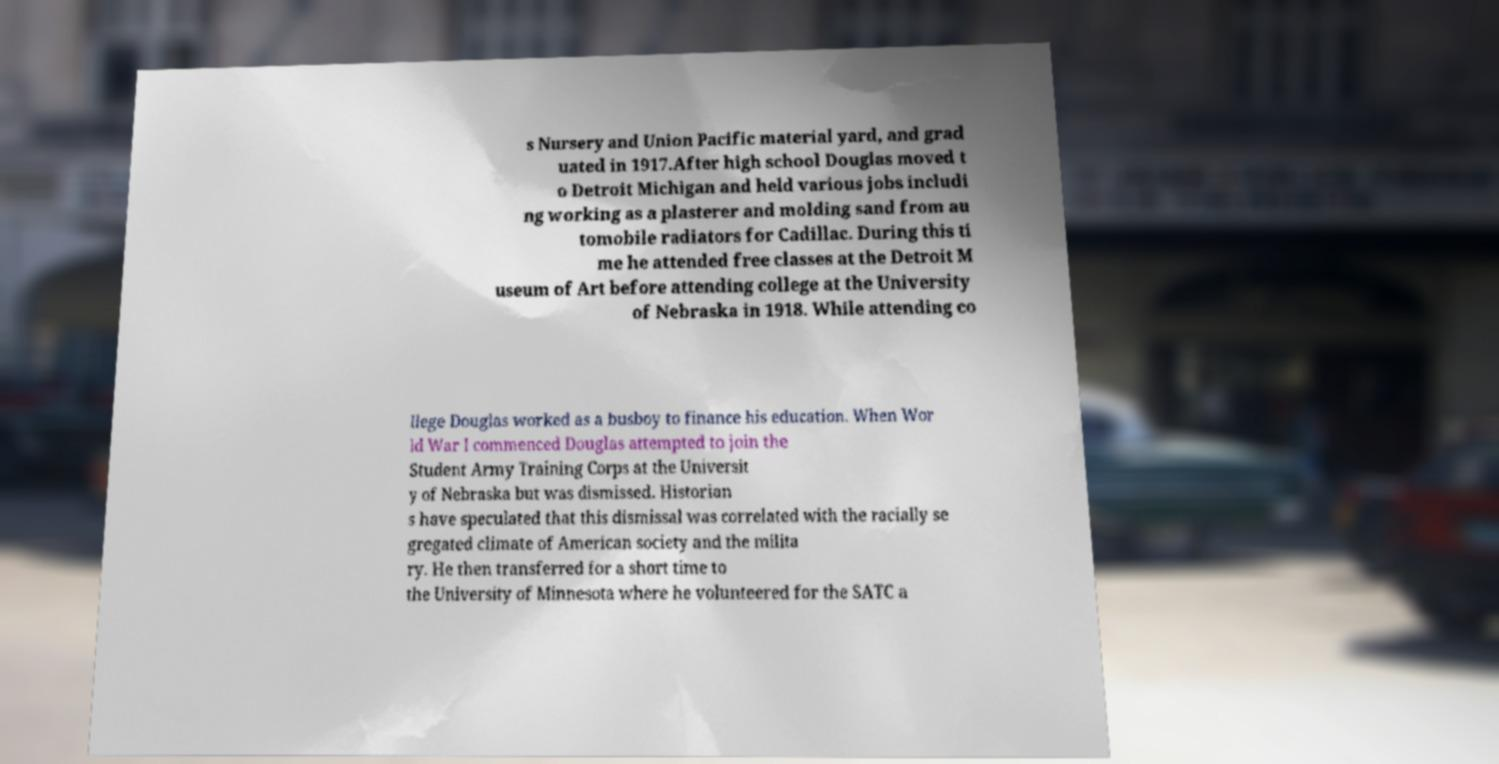Could you extract and type out the text from this image? s Nursery and Union Pacific material yard, and grad uated in 1917.After high school Douglas moved t o Detroit Michigan and held various jobs includi ng working as a plasterer and molding sand from au tomobile radiators for Cadillac. During this ti me he attended free classes at the Detroit M useum of Art before attending college at the University of Nebraska in 1918. While attending co llege Douglas worked as a busboy to finance his education. When Wor ld War I commenced Douglas attempted to join the Student Army Training Corps at the Universit y of Nebraska but was dismissed. Historian s have speculated that this dismissal was correlated with the racially se gregated climate of American society and the milita ry. He then transferred for a short time to the University of Minnesota where he volunteered for the SATC a 